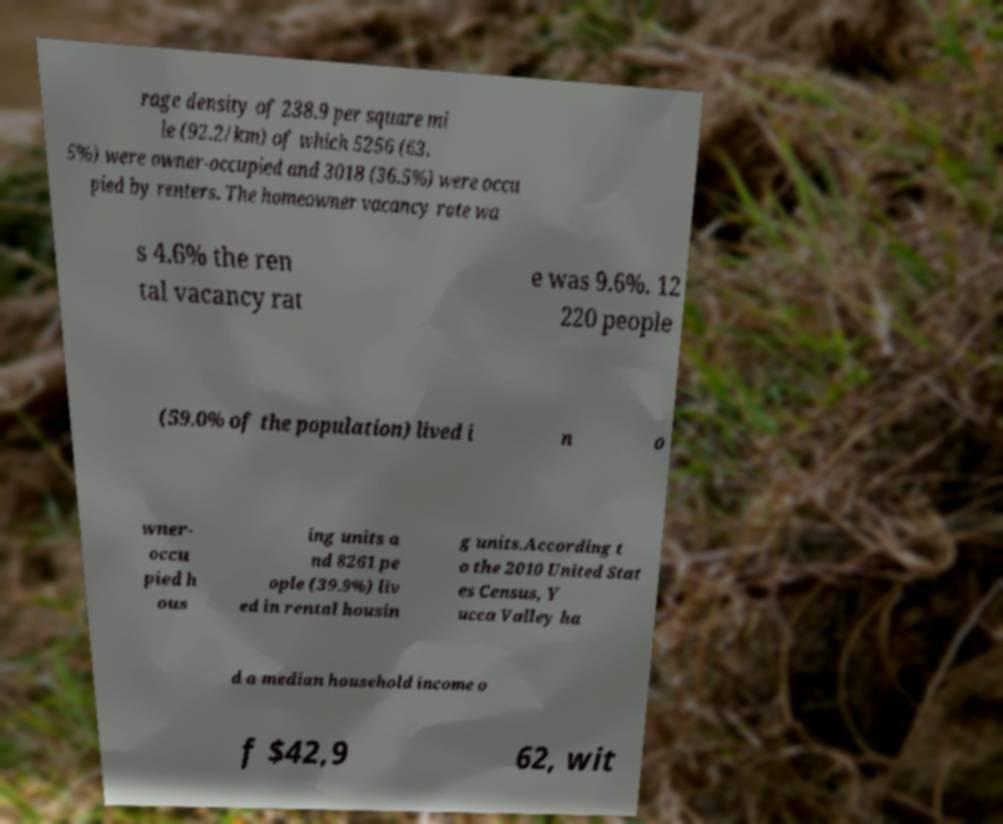For documentation purposes, I need the text within this image transcribed. Could you provide that? rage density of 238.9 per square mi le (92.2/km) of which 5256 (63. 5%) were owner-occupied and 3018 (36.5%) were occu pied by renters. The homeowner vacancy rate wa s 4.6% the ren tal vacancy rat e was 9.6%. 12 220 people (59.0% of the population) lived i n o wner- occu pied h ous ing units a nd 8261 pe ople (39.9%) liv ed in rental housin g units.According t o the 2010 United Stat es Census, Y ucca Valley ha d a median household income o f $42,9 62, wit 